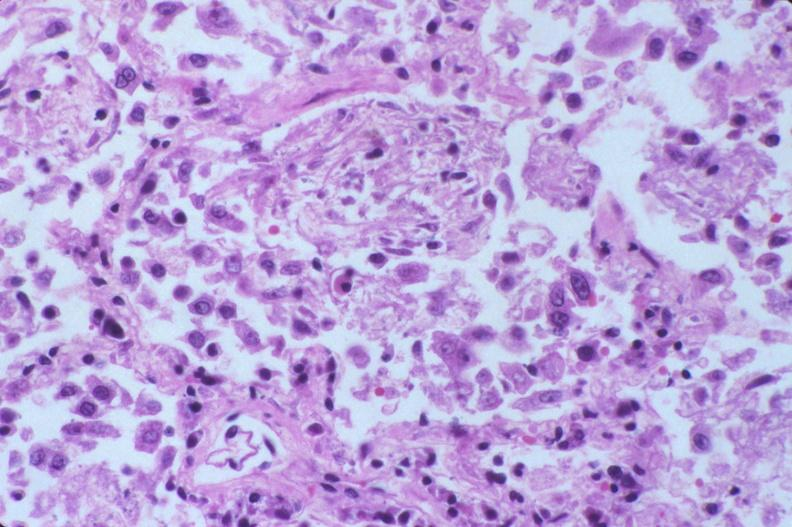s respiratory present?
Answer the question using a single word or phrase. Yes 